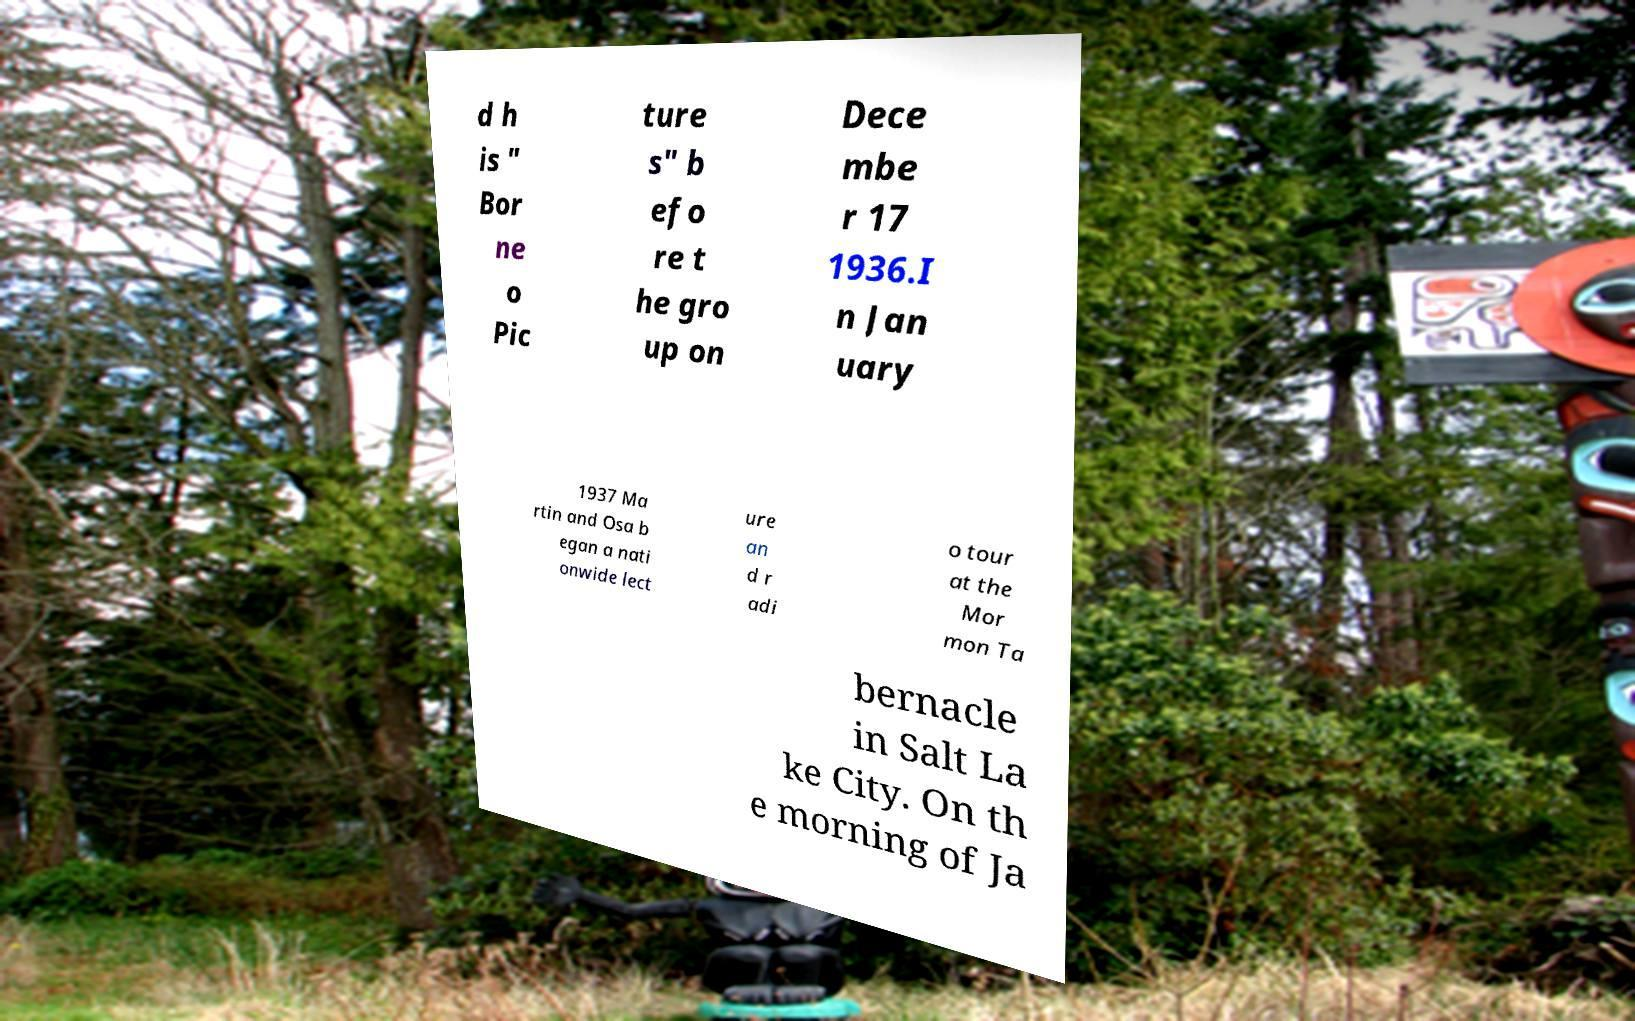Please read and relay the text visible in this image. What does it say? d h is " Bor ne o Pic ture s" b efo re t he gro up on Dece mbe r 17 1936.I n Jan uary 1937 Ma rtin and Osa b egan a nati onwide lect ure an d r adi o tour at the Mor mon Ta bernacle in Salt La ke City. On th e morning of Ja 